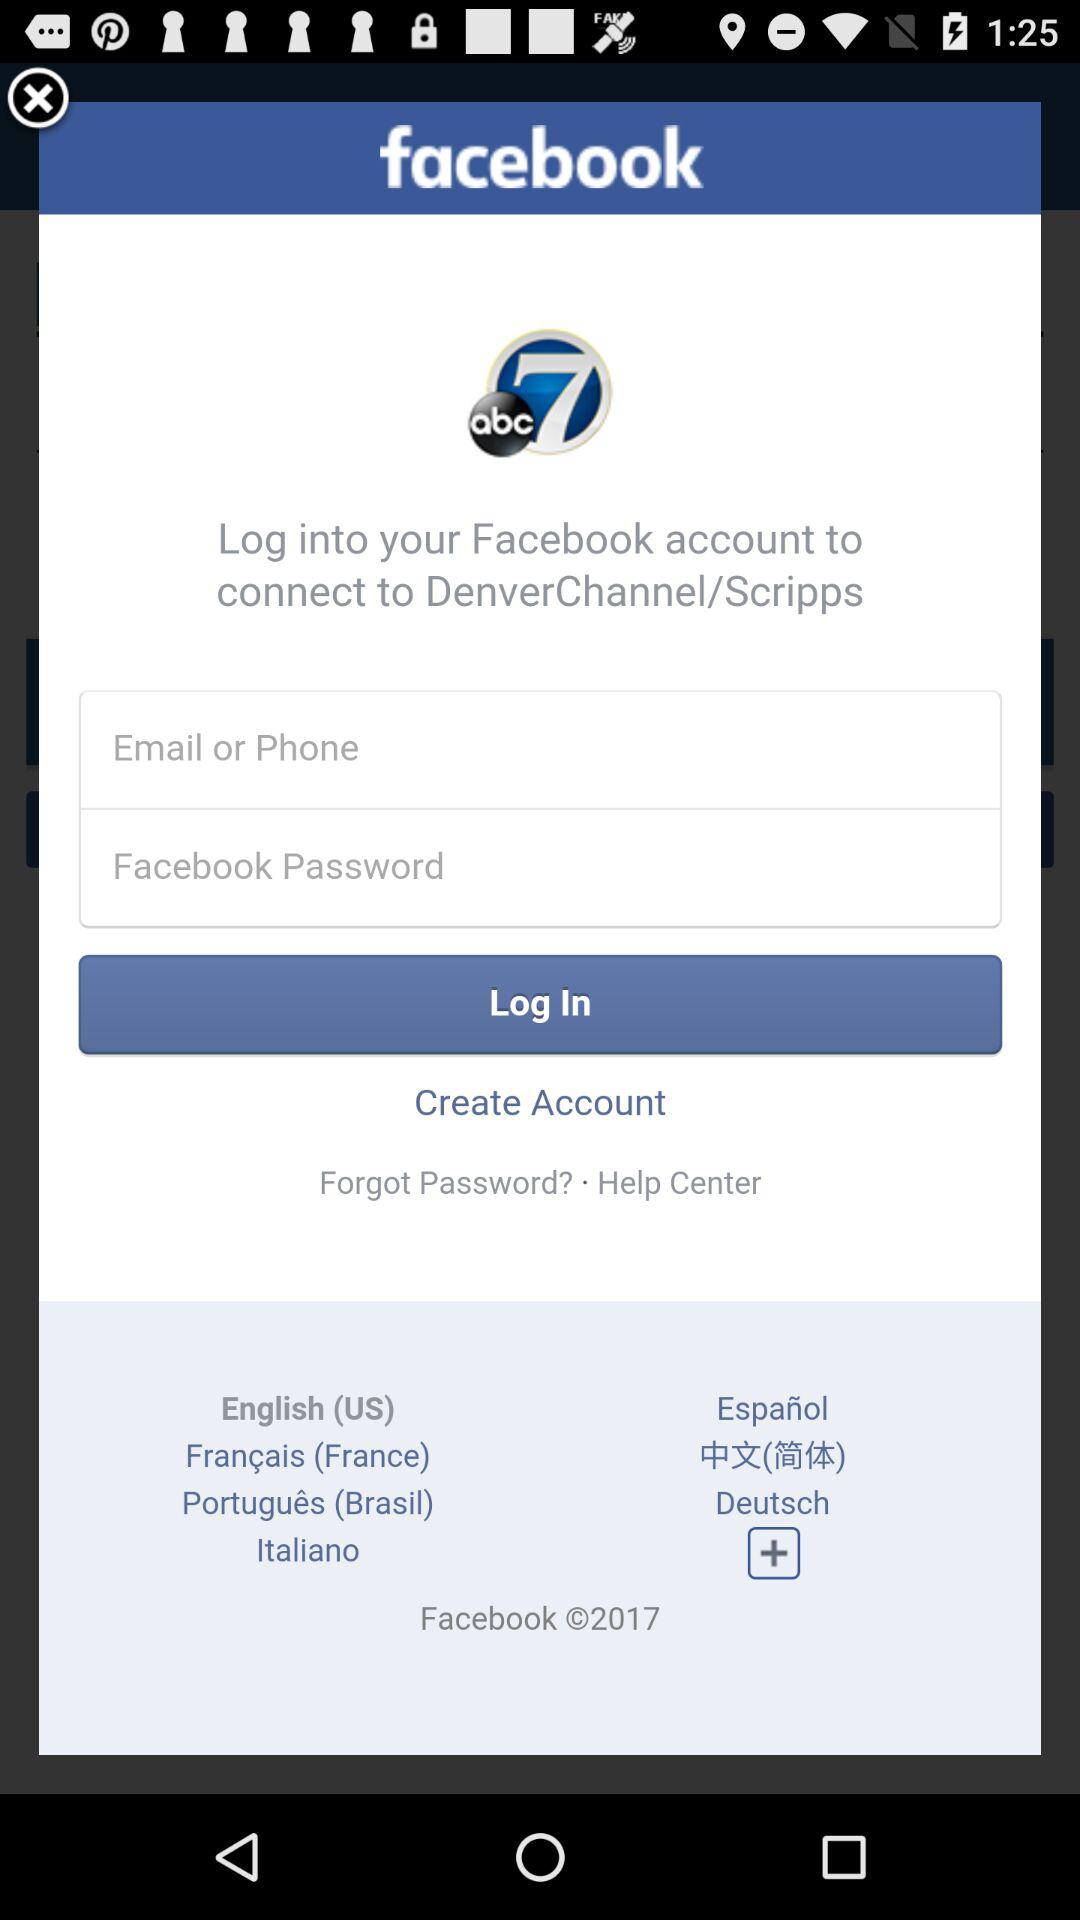What is the app name? The app name is "DenverChannel/Scripps". 